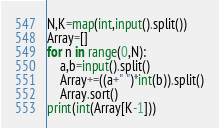Convert code to text. <code><loc_0><loc_0><loc_500><loc_500><_Python_>N,K=map(int,input().split())
Array=[]
for n in range(0,N):
    a,b=input().split()
    Array+=((a+" ")*int(b)).split()
    Array.sort()
print(int(Array[K-1]))
</code> 